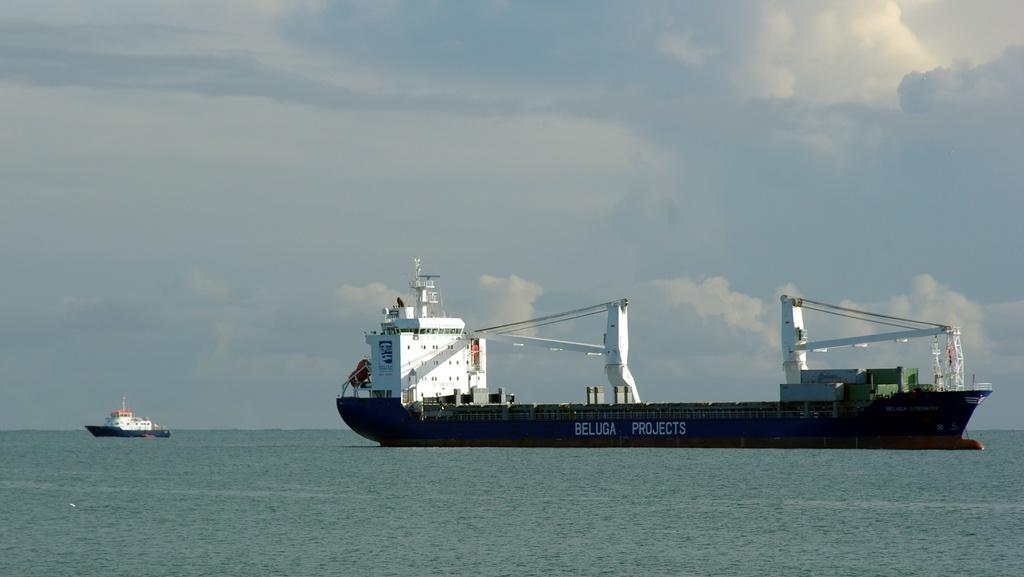What is the main feature of the image? There is an ocean in the image. What can be seen on the right side of the image? There is a ship on the right side of the image. Are there any other ships visible in the image? Yes, there is another small ship before the first ship. What is visible above the ocean in the image? The sky is visible in the image. What can be observed in the sky? There are clouds in the sky. Where is the flower located in the image? There is no flower present in the image. What type of sugar can be seen on the ship? There is no sugar visible in the image, as it features an ocean, ships, and clouds. 